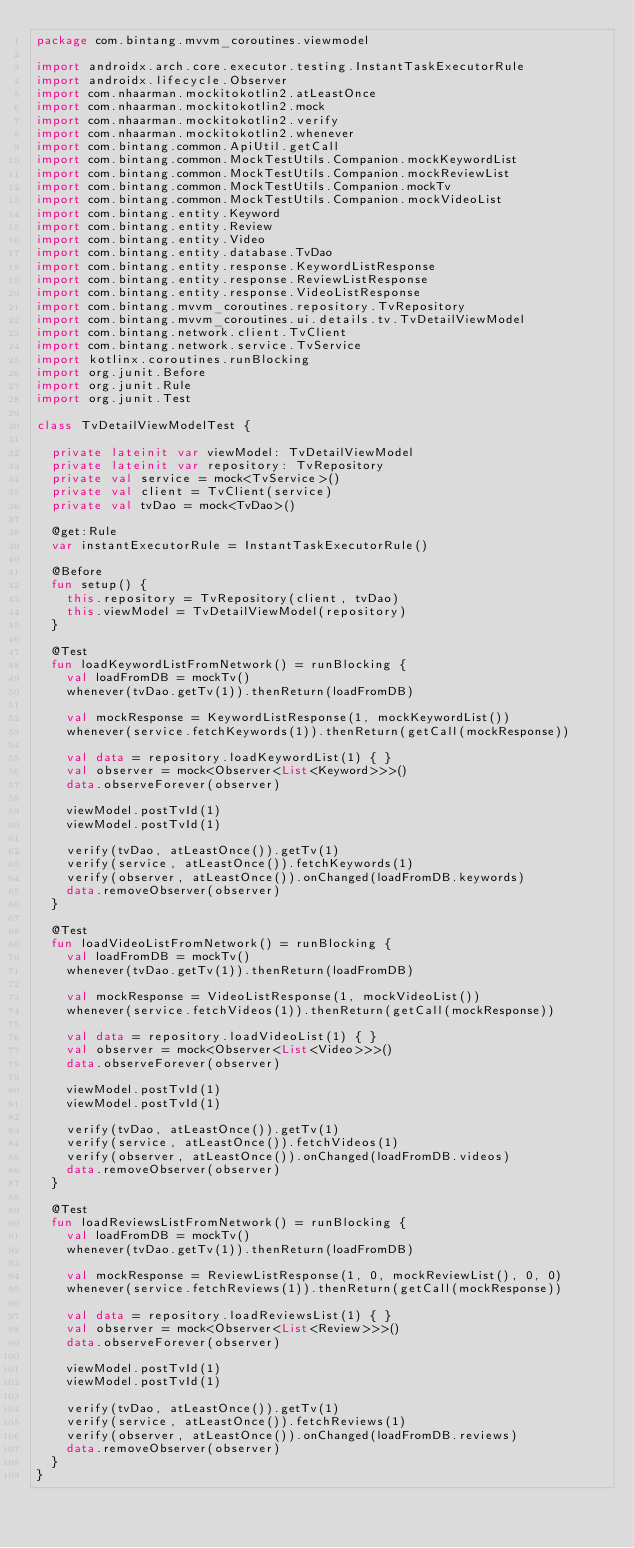Convert code to text. <code><loc_0><loc_0><loc_500><loc_500><_Kotlin_>package com.bintang.mvvm_coroutines.viewmodel

import androidx.arch.core.executor.testing.InstantTaskExecutorRule
import androidx.lifecycle.Observer
import com.nhaarman.mockitokotlin2.atLeastOnce
import com.nhaarman.mockitokotlin2.mock
import com.nhaarman.mockitokotlin2.verify
import com.nhaarman.mockitokotlin2.whenever
import com.bintang.common.ApiUtil.getCall
import com.bintang.common.MockTestUtils.Companion.mockKeywordList
import com.bintang.common.MockTestUtils.Companion.mockReviewList
import com.bintang.common.MockTestUtils.Companion.mockTv
import com.bintang.common.MockTestUtils.Companion.mockVideoList
import com.bintang.entity.Keyword
import com.bintang.entity.Review
import com.bintang.entity.Video
import com.bintang.entity.database.TvDao
import com.bintang.entity.response.KeywordListResponse
import com.bintang.entity.response.ReviewListResponse
import com.bintang.entity.response.VideoListResponse
import com.bintang.mvvm_coroutines.repository.TvRepository
import com.bintang.mvvm_coroutines.ui.details.tv.TvDetailViewModel
import com.bintang.network.client.TvClient
import com.bintang.network.service.TvService
import kotlinx.coroutines.runBlocking
import org.junit.Before
import org.junit.Rule
import org.junit.Test

class TvDetailViewModelTest {

  private lateinit var viewModel: TvDetailViewModel
  private lateinit var repository: TvRepository
  private val service = mock<TvService>()
  private val client = TvClient(service)
  private val tvDao = mock<TvDao>()

  @get:Rule
  var instantExecutorRule = InstantTaskExecutorRule()

  @Before
  fun setup() {
    this.repository = TvRepository(client, tvDao)
    this.viewModel = TvDetailViewModel(repository)
  }

  @Test
  fun loadKeywordListFromNetwork() = runBlocking {
    val loadFromDB = mockTv()
    whenever(tvDao.getTv(1)).thenReturn(loadFromDB)

    val mockResponse = KeywordListResponse(1, mockKeywordList())
    whenever(service.fetchKeywords(1)).thenReturn(getCall(mockResponse))

    val data = repository.loadKeywordList(1) { }
    val observer = mock<Observer<List<Keyword>>>()
    data.observeForever(observer)

    viewModel.postTvId(1)
    viewModel.postTvId(1)

    verify(tvDao, atLeastOnce()).getTv(1)
    verify(service, atLeastOnce()).fetchKeywords(1)
    verify(observer, atLeastOnce()).onChanged(loadFromDB.keywords)
    data.removeObserver(observer)
  }

  @Test
  fun loadVideoListFromNetwork() = runBlocking {
    val loadFromDB = mockTv()
    whenever(tvDao.getTv(1)).thenReturn(loadFromDB)

    val mockResponse = VideoListResponse(1, mockVideoList())
    whenever(service.fetchVideos(1)).thenReturn(getCall(mockResponse))

    val data = repository.loadVideoList(1) { }
    val observer = mock<Observer<List<Video>>>()
    data.observeForever(observer)

    viewModel.postTvId(1)
    viewModel.postTvId(1)

    verify(tvDao, atLeastOnce()).getTv(1)
    verify(service, atLeastOnce()).fetchVideos(1)
    verify(observer, atLeastOnce()).onChanged(loadFromDB.videos)
    data.removeObserver(observer)
  }

  @Test
  fun loadReviewsListFromNetwork() = runBlocking {
    val loadFromDB = mockTv()
    whenever(tvDao.getTv(1)).thenReturn(loadFromDB)

    val mockResponse = ReviewListResponse(1, 0, mockReviewList(), 0, 0)
    whenever(service.fetchReviews(1)).thenReturn(getCall(mockResponse))

    val data = repository.loadReviewsList(1) { }
    val observer = mock<Observer<List<Review>>>()
    data.observeForever(observer)

    viewModel.postTvId(1)
    viewModel.postTvId(1)

    verify(tvDao, atLeastOnce()).getTv(1)
    verify(service, atLeastOnce()).fetchReviews(1)
    verify(observer, atLeastOnce()).onChanged(loadFromDB.reviews)
    data.removeObserver(observer)
  }
}
</code> 